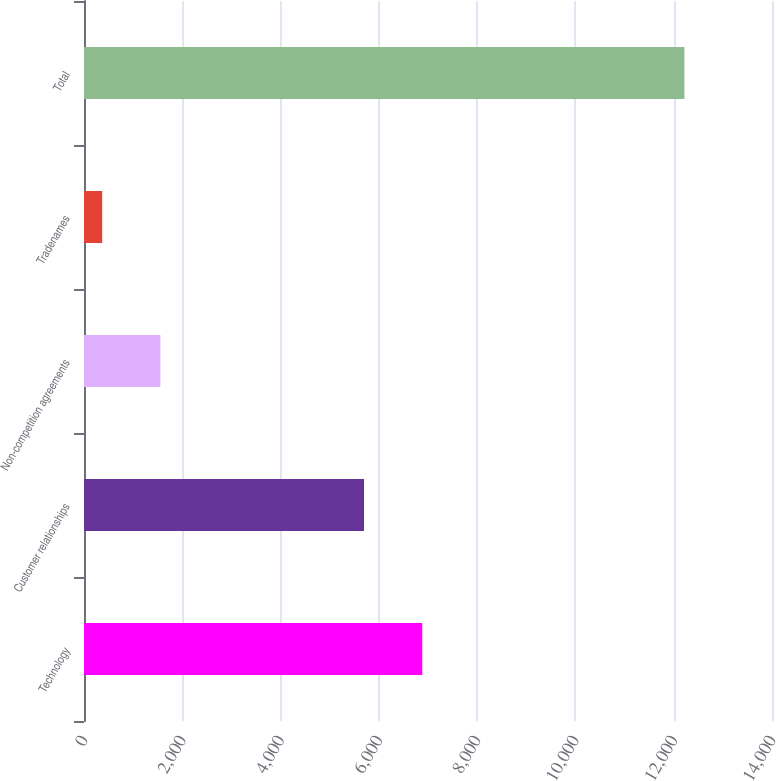Convert chart to OTSL. <chart><loc_0><loc_0><loc_500><loc_500><bar_chart><fcel>Technology<fcel>Customer relationships<fcel>Non-competition agreements<fcel>Tradenames<fcel>Total<nl><fcel>6882.8<fcel>5698<fcel>1554.8<fcel>370<fcel>12218<nl></chart> 